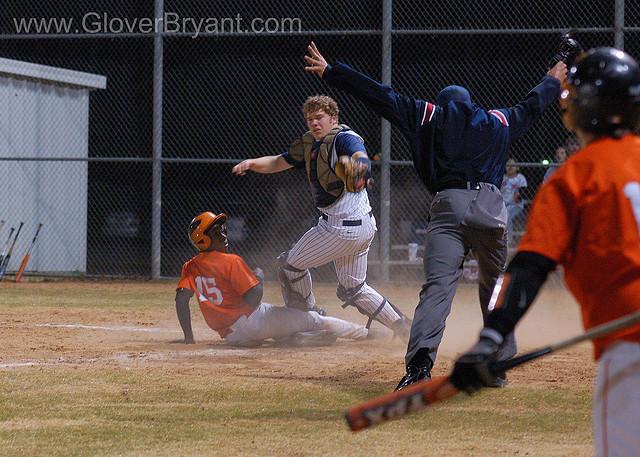How many players have on orange shirts?
Concise answer only. 2. Is the runner out?
Keep it brief. No. How many orange bats are there?
Concise answer only. 1. 